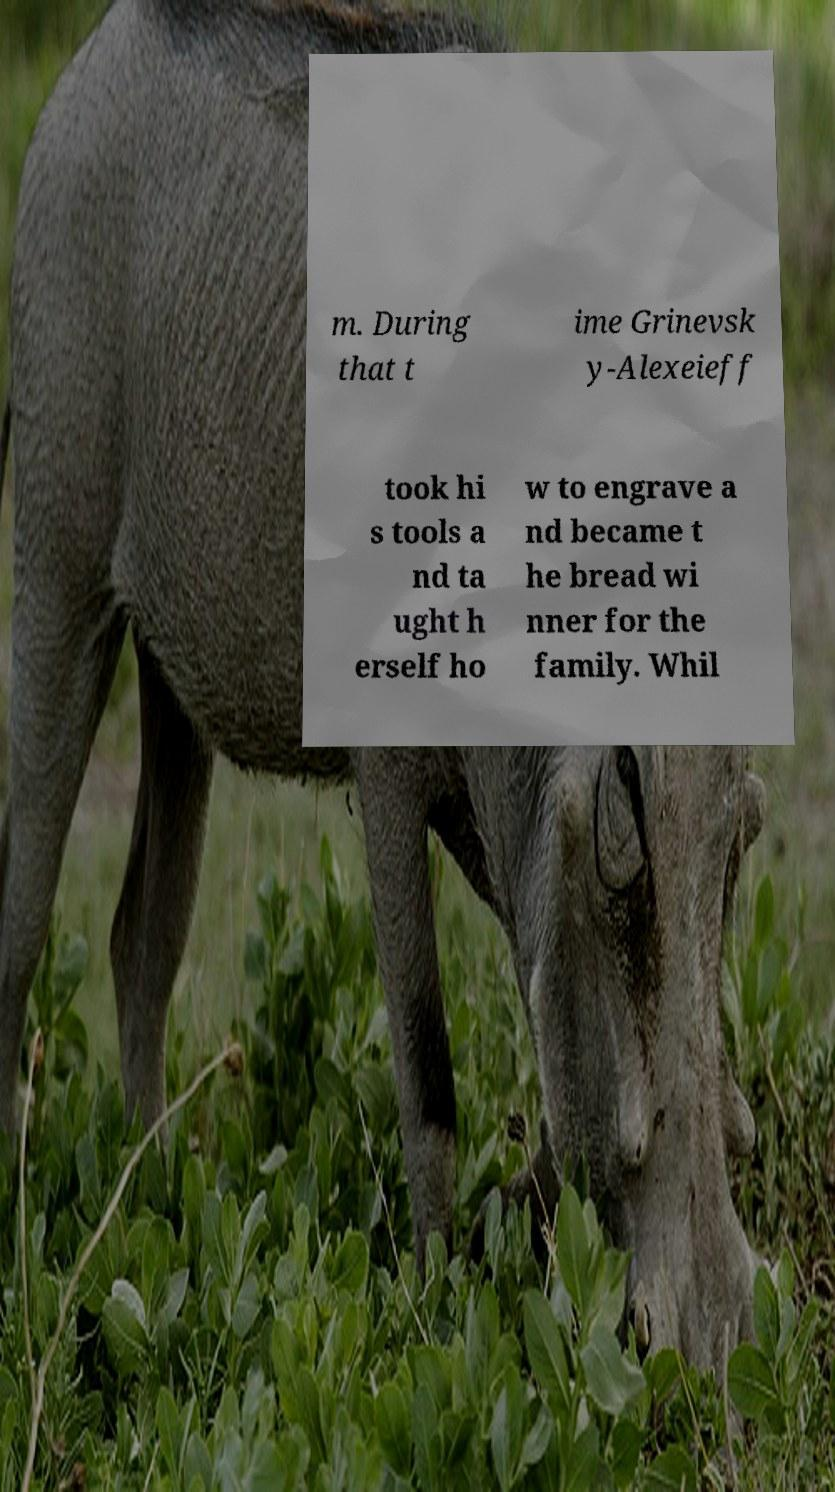Could you assist in decoding the text presented in this image and type it out clearly? m. During that t ime Grinevsk y-Alexeieff took hi s tools a nd ta ught h erself ho w to engrave a nd became t he bread wi nner for the family. Whil 